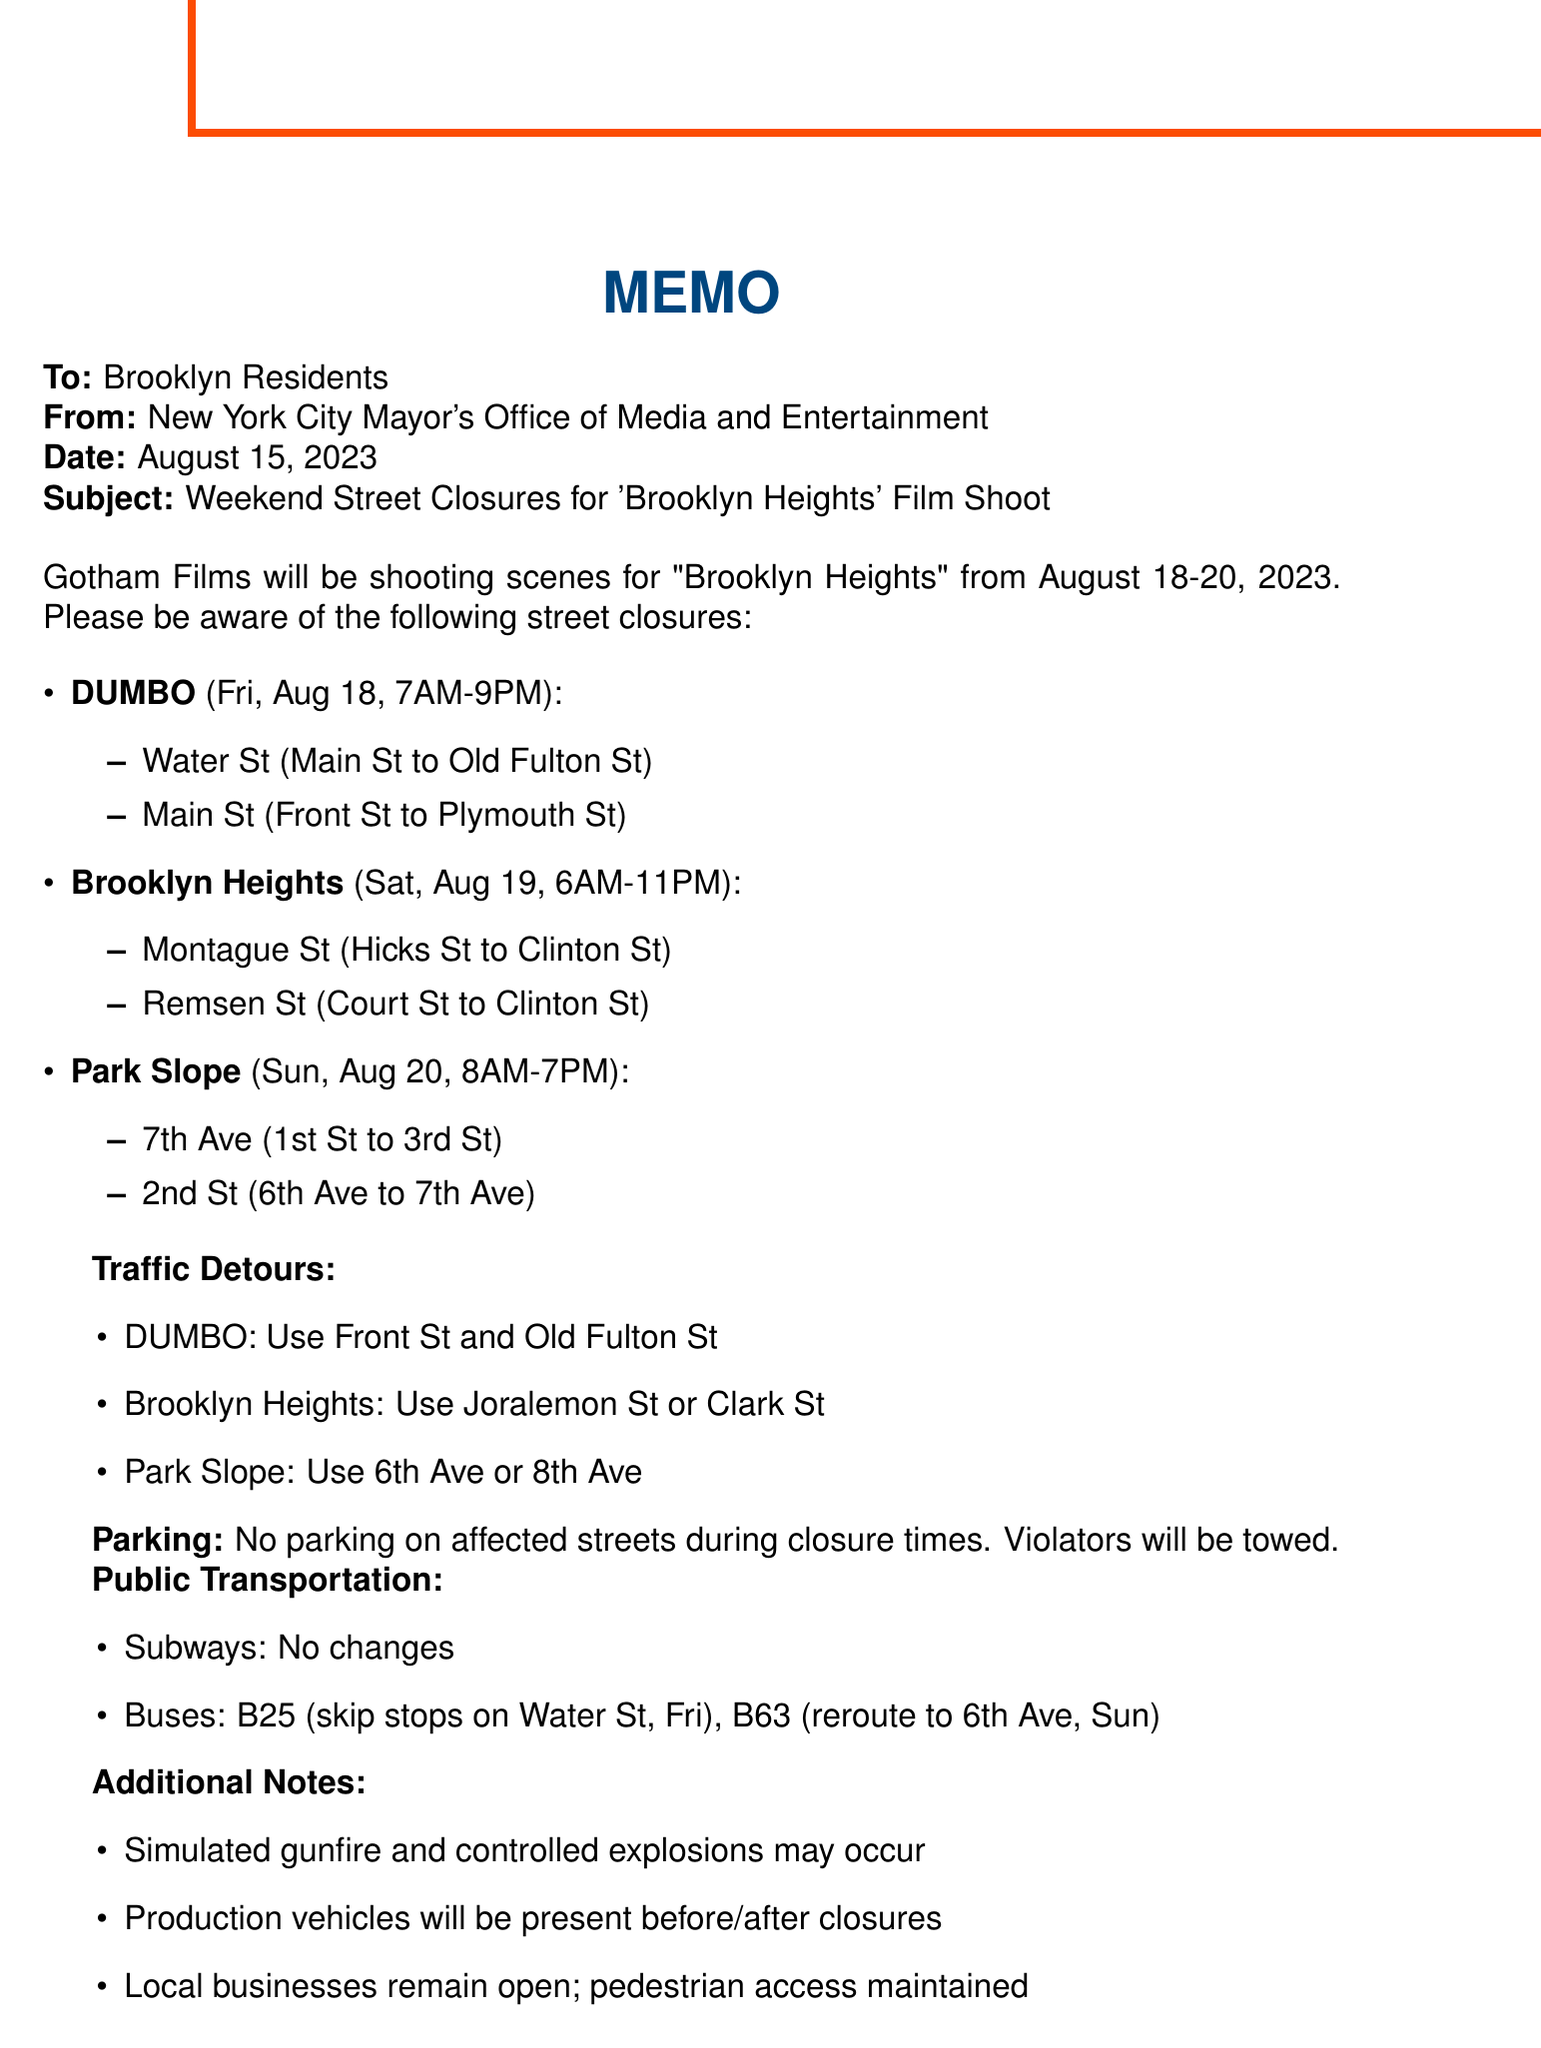What is the film title? The film title is explicitly stated in the introduction section of the memo.
Answer: Brooklyn Heights Who is the production company? The memo mentions that Gotham Films is producing the film.
Answer: Gotham Films What are the closure times for Brooklyn Heights? The closure times are detailed in the affected areas section for Brooklyn Heights.
Answer: Saturday, August 19, 6:00 AM - 11:00 PM What streets are affected in Park Slope? The affected streets are listed under the Park Slope section of the memo.
Answer: 7th Avenue between 1st Street and 3rd Street, 2nd Street between 6th Avenue and 7th Avenue What is the detour route for DUMBO? The detour route for DUMBO is specified in the traffic detours section of the memo.
Answer: Use Front Street and Old Fulton Street as alternatives How much economic activity is expected from the film shoot? The economic impact is summarized in the community benefits section of the memo.
Answer: Approximately $500,000 What changes will occur to the B63 bus route? The memo provides details about the bus changes, specifically for the B63 route.
Answer: Will be rerouted along 6th Avenue in Park Slope on Sunday Who should residents contact for more information? The memo lists contact information for Sarah Johnson and the city film office for inquiries.
Answer: Sarah Johnson What restrictions are in place regarding parking? The memo clearly states the parking restrictions during the closure times.
Answer: No parking will be allowed on affected streets during closure times 